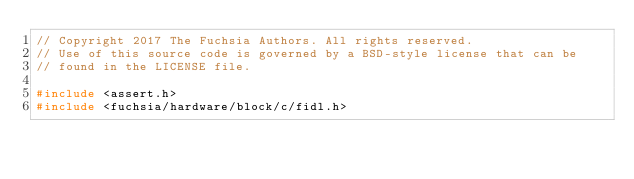Convert code to text. <code><loc_0><loc_0><loc_500><loc_500><_C++_>// Copyright 2017 The Fuchsia Authors. All rights reserved.
// Use of this source code is governed by a BSD-style license that can be
// found in the LICENSE file.

#include <assert.h>
#include <fuchsia/hardware/block/c/fidl.h></code> 